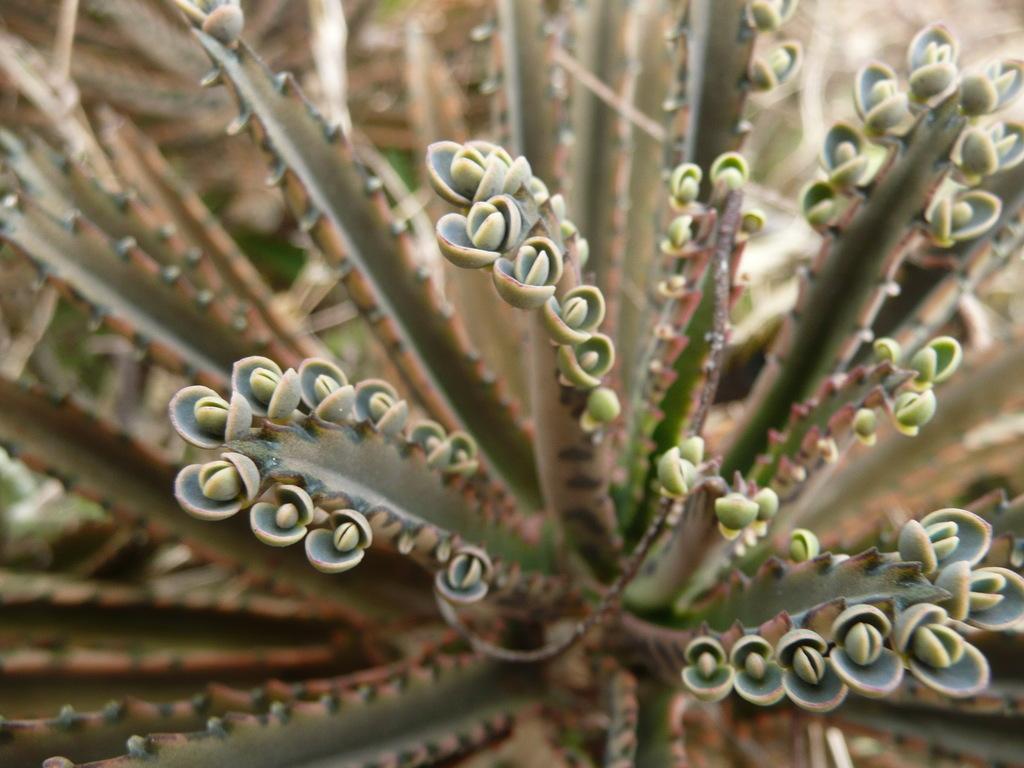In one or two sentences, can you explain what this image depicts? In the center of the image, we can see a plant along with buds. 